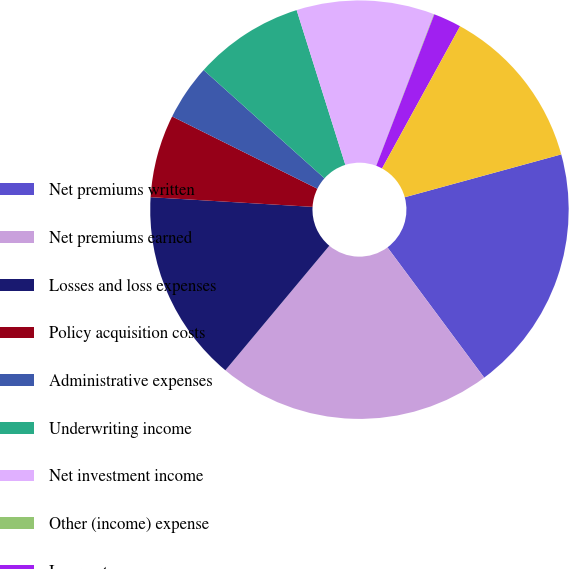<chart> <loc_0><loc_0><loc_500><loc_500><pie_chart><fcel>Net premiums written<fcel>Net premiums earned<fcel>Losses and loss expenses<fcel>Policy acquisition costs<fcel>Administrative expenses<fcel>Underwriting income<fcel>Net investment income<fcel>Other (income) expense<fcel>Income tax expense<fcel>Net income<nl><fcel>19.09%<fcel>21.24%<fcel>14.88%<fcel>6.4%<fcel>4.28%<fcel>8.52%<fcel>10.64%<fcel>0.04%<fcel>2.16%<fcel>12.76%<nl></chart> 